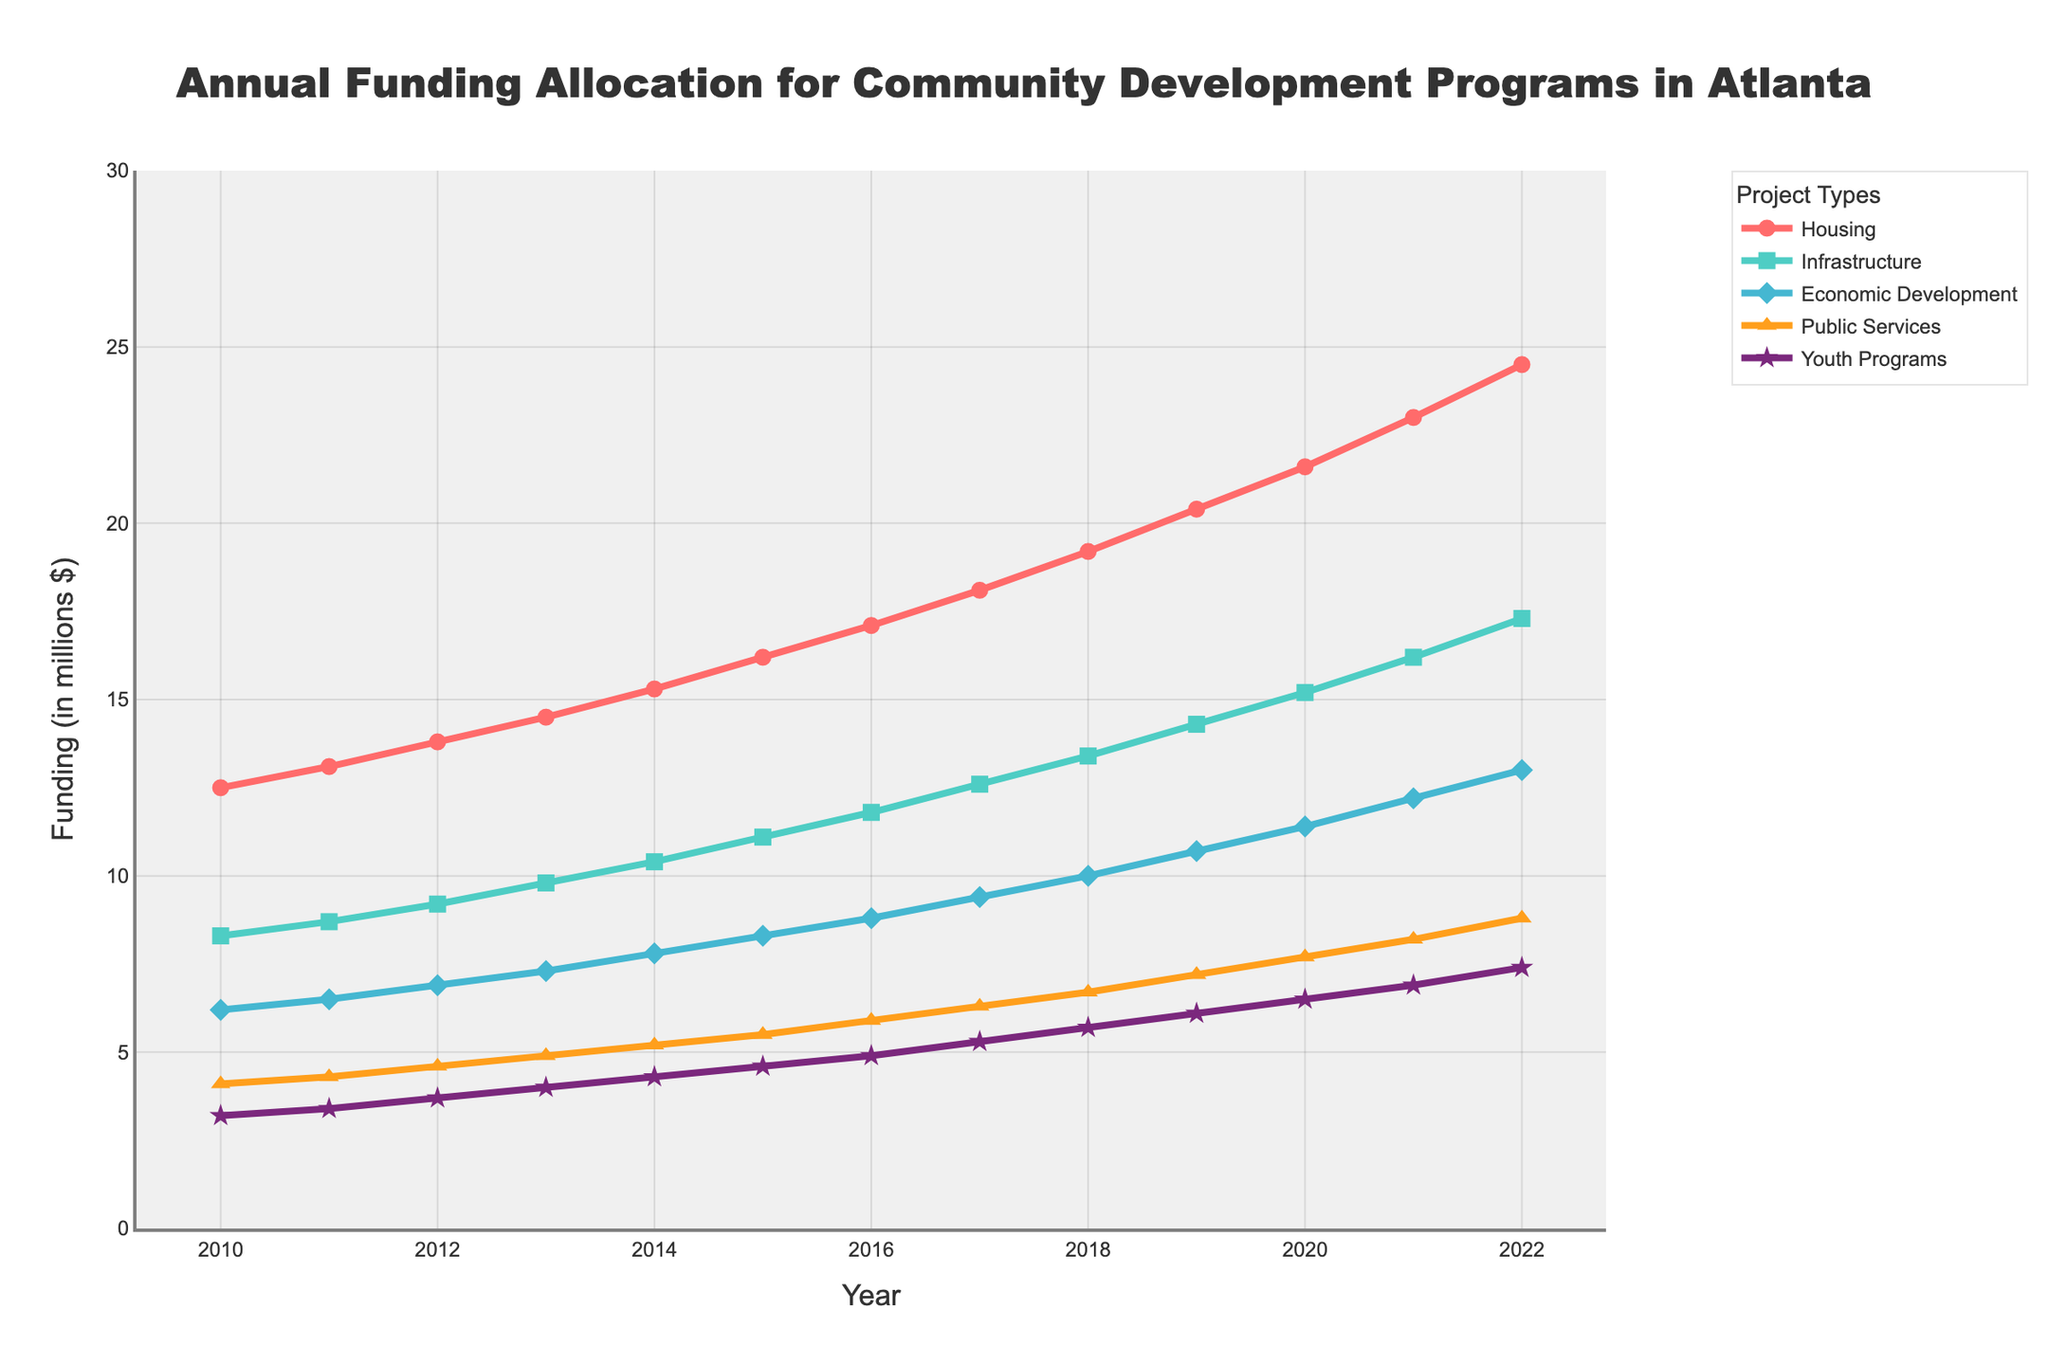What is the total funding for Housing and Youth Programs in 2022? To get the total funding for Housing and Youth Programs in 2022, add the amounts allocated to both categories for that year. According to the data, Housing received 24.5 million, and Youth Programs received 7.4 million. The total is 24.5 + 7.4 = 31.9 million.
Answer: 31.9 million Which project type received the least funding in 2010? Refer to the figure for 2010 and compare the funding amounts for the different project types. Housing received 12.5 million, Infrastructure got 8.3 million, Economic Development got 6.2 million, Public Services got 4.1 million, and Youth Programs got 3.2 million. The least funding went to Youth Programs with 3.2 million.
Answer: Youth Programs How much did the funding for Public Services increase from 2016 to 2022? Calculate the difference in funding for Public Services between 2016 and 2022. In 2016, it was 5.9 million, and in 2022, it was 8.8 million. The increase is 8.8 - 5.9 = 2.9 million.
Answer: 2.9 million Which project type shows the highest growth rate from 2010 to 2022? To determine the highest growth rate, compare the initial and final funding amounts for each project type between 2010 and 2022. Calculate the difference and consider the initial values. Housing grew from 12.5 to 24.5 (12 million), Infrastructure from 8.3 to 17.3 (9 million), Economic Development from 6.2 to 13.0 (6.8 million), Public Services from 4.1 to 8.8 (4.7 million), and Youth Programs from 3.2 to 7.4 (4.2 million). Housing shows the highest growth rate with a 12 million increase.
Answer: Housing In which year did Economic Development funding surpass 10 million for the first time? Check the sequential funding amounts for Economic Development and identify the year the funding amount exceeds 10 million. In 2018, it reached 10 million exactly, and in 2019, it surpassed it with 10.7 million. Therefore, 2019 is the first year it surpassed 10 million.
Answer: 2019 What is the average annual funding for Infrastructure from 2010 to 2015? Calculate the sum of Infrastructure funding from 2010 to 2015 and then divide it by the number of years. (8.3 + 8.7 + 9.2 + 9.8 + 10.4 + 11.1) / 6 = 57.5 / 6 = 9.58 million.
Answer: 9.58 million Which project type had the smallest increase in funding between 2015 and 2022? To find the smallest increase, compare the funding amounts from 2015 to 2022 for each project type and identify the smallest difference. Housing increased by 24.5 - 16.2 = 8.3 million, Infrastructure by 17.3 - 11.1 = 6.2 million, Economic Development by 13.0 - 8.3 = 4.7 million, Public Services by 8.8 - 5.5 = 3.3 million, and Youth Programs by 7.4 - 4.6 = 2.8 million. Youth Programs had the smallest increase with 2.8 million.
Answer: Youth Programs How does the funding for Housing in 2020 compare to Infrastructure in the same year? Look at the amounts allocated for Housing and Infrastructure in 2020. Housing received 21.6 million while Infrastructure got 15.2 million. Housing received more funding in 2020.
Answer: Housing received more What is the combined funding amount for Public Services and Youth Programs in 2013? Add the amounts allocated to both Public Services and Youth Programs in 2013. Public Services received 4.9 million, and Youth Programs got 4.0 million. The combined total is 4.9 + 4.0 = 8.9 million.
Answer: 8.9 million Which project type received continuous yearly funding increases from 2010 to 2022? Analyze the trend lines for each project type from 2010 to 2022. All categories (Housing, Infrastructure, Economic Development, Public Services, and Youth Programs) show continuous yearly increases.
Answer: All project types 